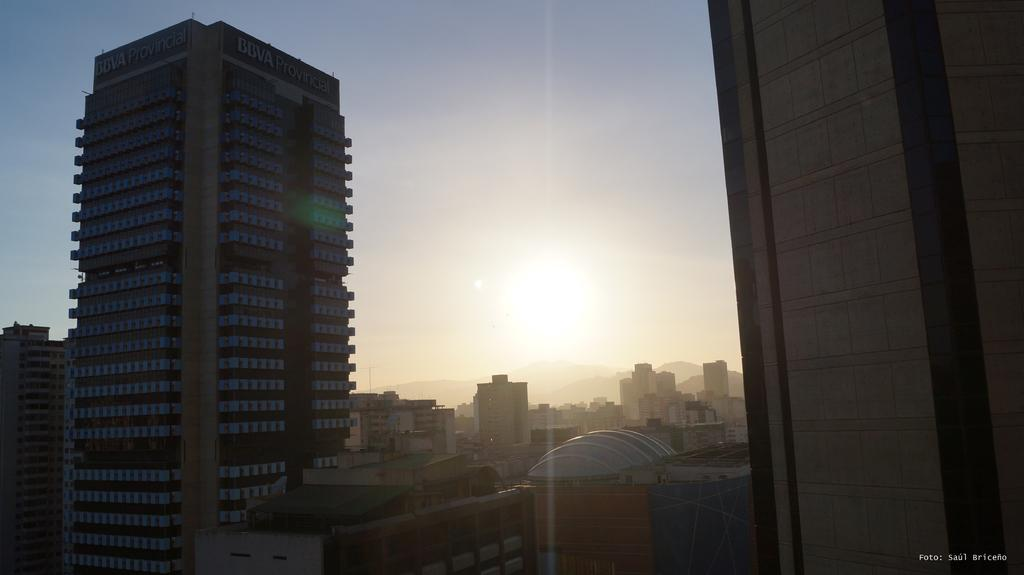What type of structures can be seen in the image? There are many buildings in the image. What natural feature is visible in the background of the image? There are mountains visible in the background of the image. Can the sun be seen in the image? Yes, the sun is observable in the image. What else is visible in the image besides the buildings and mountains? The sky is visible in the image. What color is the kite flying in the image? There is no kite present in the image. What type of house is visible in the image? The image does not show a house; it features many buildings. Can you describe the underwear worn by the person in the image? There is no person present in the image, and therefore no underwear can be observed. 